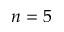Convert formula to latex. <formula><loc_0><loc_0><loc_500><loc_500>n = 5</formula> 